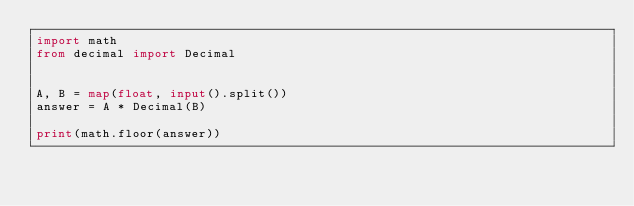Convert code to text. <code><loc_0><loc_0><loc_500><loc_500><_Python_>import math
from decimal import Decimal


A, B = map(float, input().split())
answer = A * Decimal(B)

print(math.floor(answer))</code> 